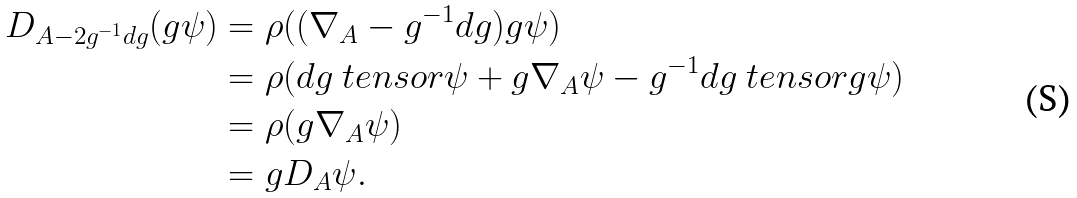Convert formula to latex. <formula><loc_0><loc_0><loc_500><loc_500>D _ { A - 2 g ^ { - 1 } d g } ( g \psi ) & = \rho ( ( \nabla _ { A } - g ^ { - 1 } d g ) g \psi ) \\ & = \rho ( d g \ t e n s o r \psi + g \nabla _ { A } \psi - g ^ { - 1 } d g \ t e n s o r g \psi ) \\ & = \rho ( g \nabla _ { A } \psi ) \\ & = g D _ { A } \psi .</formula> 